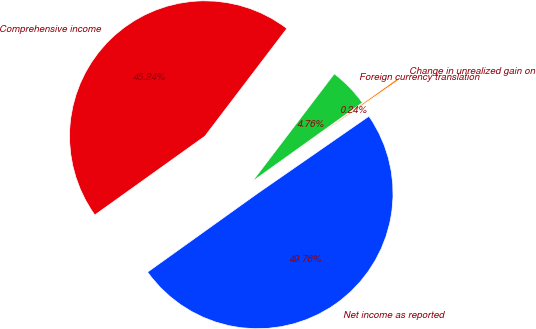Convert chart. <chart><loc_0><loc_0><loc_500><loc_500><pie_chart><fcel>Net income as reported<fcel>Change in unrealized gain on<fcel>Foreign currency translation<fcel>Comprehensive income<nl><fcel>49.76%<fcel>0.24%<fcel>4.76%<fcel>45.24%<nl></chart> 